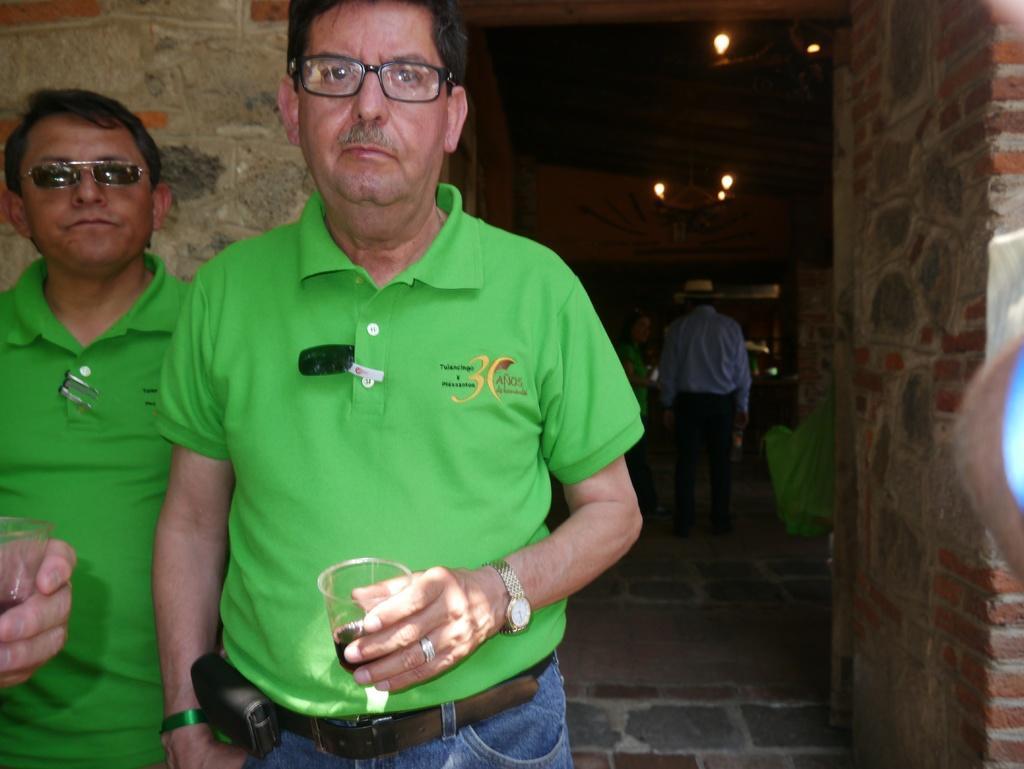Can you describe this image briefly? In this image I can see on the left side two men are standing and also they are holding the wine glasses. At the top there are lights and on the right side there is the brick wall. 